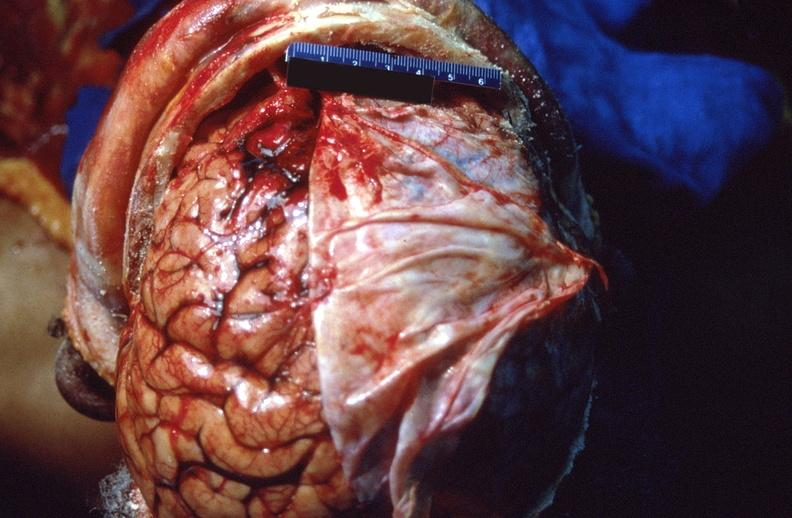what is present?
Answer the question using a single word or phrase. Nervous 